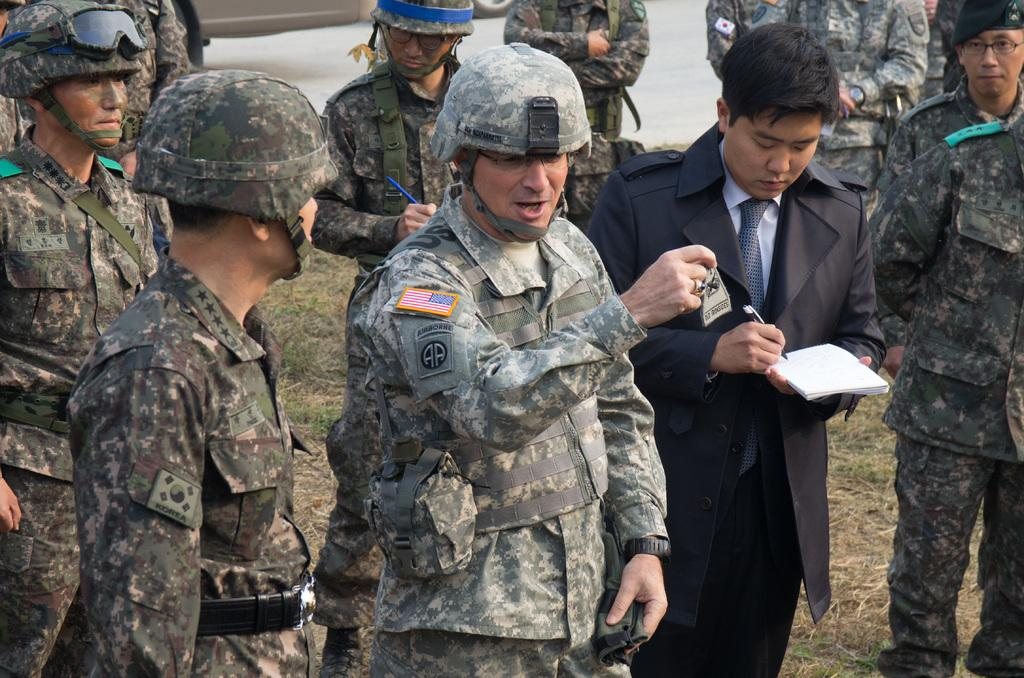What are the people in the image doing? There are people standing in the image. Can you describe what one person is holding? One person is holding a book. What is another person holding in the image? One person is holding a pen. What type of clothing are some people wearing? Some people are wearing military dresses. How many clocks can be seen in the image? There are no clocks visible in the image. What type of hat is the baby wearing in the image? There is no baby present in the image, so it is not possible to answer that question. 